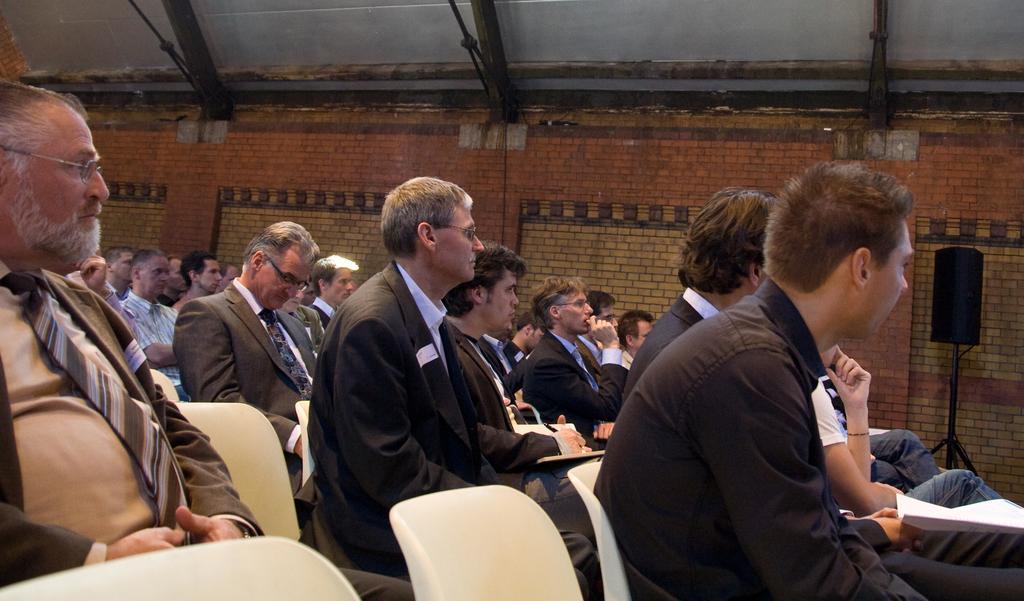In one or two sentences, can you explain what this image depicts? People are sitting on chairs. One person is holding a paper. In-front of this brick wall there is a speaker. Another person is holding a pen and book. Most of the people wore suits. 